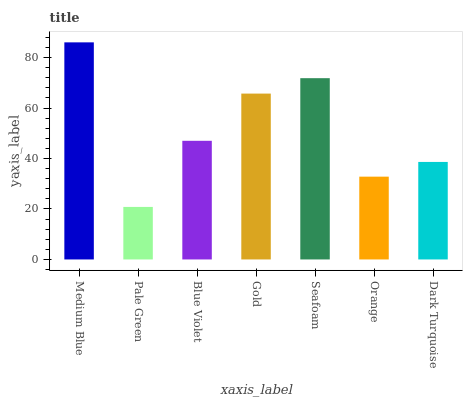Is Pale Green the minimum?
Answer yes or no. Yes. Is Medium Blue the maximum?
Answer yes or no. Yes. Is Blue Violet the minimum?
Answer yes or no. No. Is Blue Violet the maximum?
Answer yes or no. No. Is Blue Violet greater than Pale Green?
Answer yes or no. Yes. Is Pale Green less than Blue Violet?
Answer yes or no. Yes. Is Pale Green greater than Blue Violet?
Answer yes or no. No. Is Blue Violet less than Pale Green?
Answer yes or no. No. Is Blue Violet the high median?
Answer yes or no. Yes. Is Blue Violet the low median?
Answer yes or no. Yes. Is Gold the high median?
Answer yes or no. No. Is Pale Green the low median?
Answer yes or no. No. 